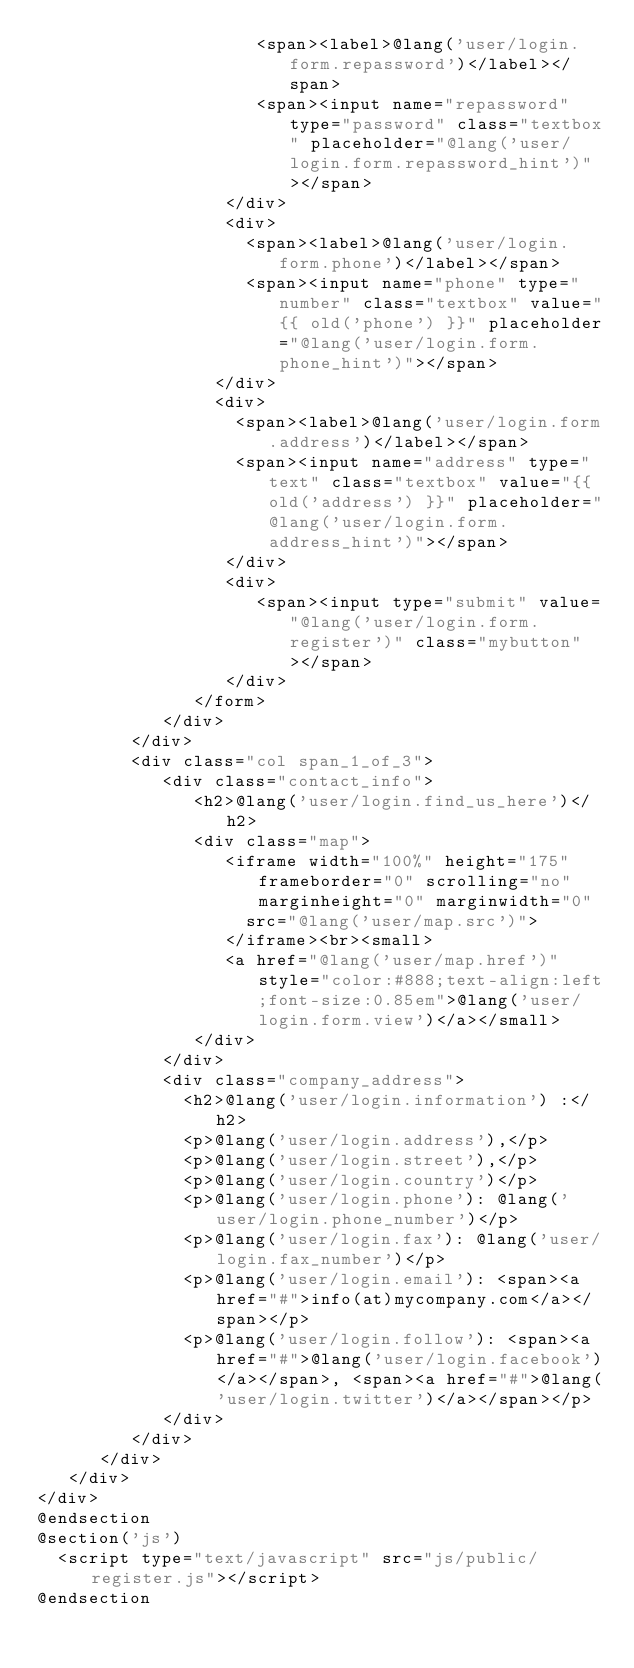<code> <loc_0><loc_0><loc_500><loc_500><_PHP_>                     <span><label>@lang('user/login.form.repassword')</label></span>
                     <span><input name="repassword" type="password" class="textbox" placeholder="@lang('user/login.form.repassword_hint')"></span>
                  </div>
                  <div>
                    <span><label>@lang('user/login.form.phone')</label></span>
                    <span><input name="phone" type="number" class="textbox" value="{{ old('phone') }}" placeholder="@lang('user/login.form.phone_hint')"></span>
                 </div>
                 <div>
                   <span><label>@lang('user/login.form.address')</label></span>
                   <span><input name="address" type="text" class="textbox" value="{{ old('address') }}" placeholder="@lang('user/login.form.address_hint')"></span>
                  </div>
                  <div>
                     <span><input type="submit" value="@lang('user/login.form.register')" class="mybutton"></span>
                  </div>
               </form>
            </div>
         </div>
         <div class="col span_1_of_3">
            <div class="contact_info">
               <h2>@lang('user/login.find_us_here')</h2>
               <div class="map">
                  <iframe width="100%" height="175" frameborder="0" scrolling="no" marginheight="0" marginwidth="0"
                    src="@lang('user/map.src')">
                  </iframe><br><small>
                  <a href="@lang('user/map.href')" style="color:#888;text-align:left;font-size:0.85em">@lang('user/login.form.view')</a></small>
               </div>
            </div>
            <div class="company_address">
              <h2>@lang('user/login.information') :</h2>
              <p>@lang('user/login.address'),</p>
              <p>@lang('user/login.street'),</p>
              <p>@lang('user/login.country')</p>
              <p>@lang('user/login.phone'): @lang('user/login.phone_number')</p>
              <p>@lang('user/login.fax'): @lang('user/login.fax_number')</p>
              <p>@lang('user/login.email'): <span><a href="#">info(at)mycompany.com</a></span></p>
              <p>@lang('user/login.follow'): <span><a href="#">@lang('user/login.facebook')</a></span>, <span><a href="#">@lang('user/login.twitter')</a></span></p>
            </div>
         </div>
      </div>
   </div>
</div>
@endsection
@section('js')
  <script type="text/javascript" src="js/public/register.js"></script>
@endsection</code> 